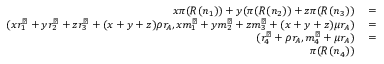<formula> <loc_0><loc_0><loc_500><loc_500>\begin{array} { r l r } { x \pi ( R ( n _ { 1 } ) ) + y ( \pi ( R ( n _ { 2 } ) ) + z \pi ( R ( n _ { 3 } ) ) } & = } \\ { ( x r _ { 1 } ^ { \perp } + y r _ { 2 } ^ { \perp } + z r _ { 3 } ^ { \perp } + ( x + y + z ) \rho r _ { A } , x m _ { 1 } ^ { \perp } + y m _ { 2 } ^ { \perp } + z m _ { 3 } ^ { \perp } + ( x + y + z ) \mu r _ { A } ) } & = } \\ { ( r _ { 4 } ^ { \perp } + \rho r _ { A } , m _ { 4 } ^ { \perp } + \mu r _ { A } ) } & = } \\ { \pi ( R ( n _ { 4 } ) ) } \end{array}</formula> 